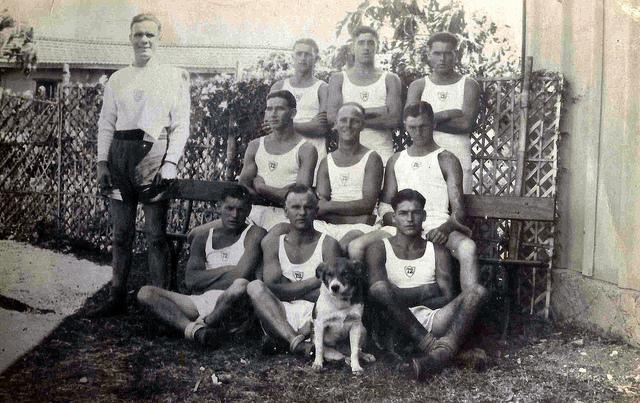What type of tops are the men on the right wearing? tank tops 